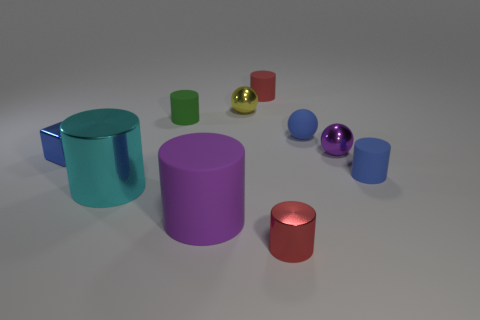Subtract all red spheres. How many red cylinders are left? 2 Subtract all purple metallic spheres. How many spheres are left? 2 Subtract all green cylinders. How many cylinders are left? 5 Subtract 3 cylinders. How many cylinders are left? 3 Subtract all brown balls. Subtract all green cylinders. How many balls are left? 3 Add 7 tiny blue metallic cylinders. How many tiny blue metallic cylinders exist? 7 Subtract 0 brown spheres. How many objects are left? 10 Subtract all cylinders. How many objects are left? 4 Subtract all large gray matte things. Subtract all purple shiny spheres. How many objects are left? 9 Add 2 small rubber things. How many small rubber things are left? 6 